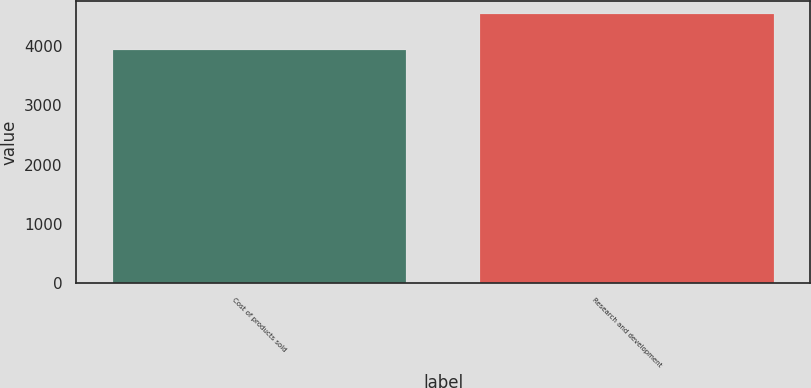Convert chart. <chart><loc_0><loc_0><loc_500><loc_500><bar_chart><fcel>Cost of products sold<fcel>Research and development<nl><fcel>3932<fcel>4534<nl></chart> 